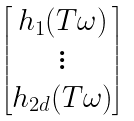Convert formula to latex. <formula><loc_0><loc_0><loc_500><loc_500>\begin{bmatrix} h _ { 1 } ( T \omega ) \\ \vdots \\ h _ { 2 d } ( T \omega ) \end{bmatrix}</formula> 